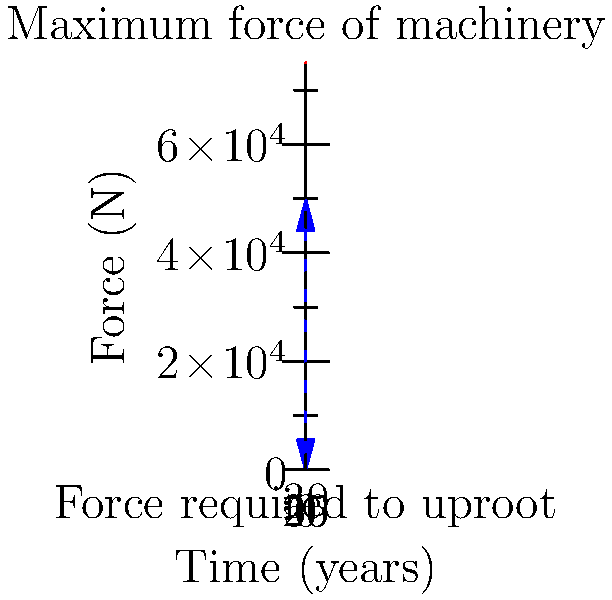A palm oil company plans to clear an area of mature palm trees for replanting. The force required to uproot a palm tree increases over time according to the function $F(t) = 50000(1-e^{-0.1t})$, where $F$ is the force in Newtons and $t$ is the tree's age in years. If the company's machinery can exert a maximum force of 75,000 N, what is the maximum age of trees that can be uprooted without damaging the equipment? To solve this problem, we need to follow these steps:

1) The maximum force the machinery can exert is 75,000 N. We need to find when the force required to uproot the tree equals this value.

2) We can express this as an equation:
   $75000 = 50000(1-e^{-0.1t})$

3) Divide both sides by 50000:
   $1.5 = 1-e^{-0.1t}$

4) Subtract both sides from 1:
   $-0.5 = -e^{-0.1t}$

5) Take the natural log of both sides:
   $\ln(0.5) = -0.1t$

6) Divide both sides by -0.1:
   $\frac{\ln(0.5)}{-0.1} = t$

7) Calculate the value:
   $t \approx 6.93$ years

8) Since we can't uproot partial trees, we round down to the nearest whole year.

Therefore, the maximum age of trees that can be uprooted is 6 years.
Answer: 6 years 